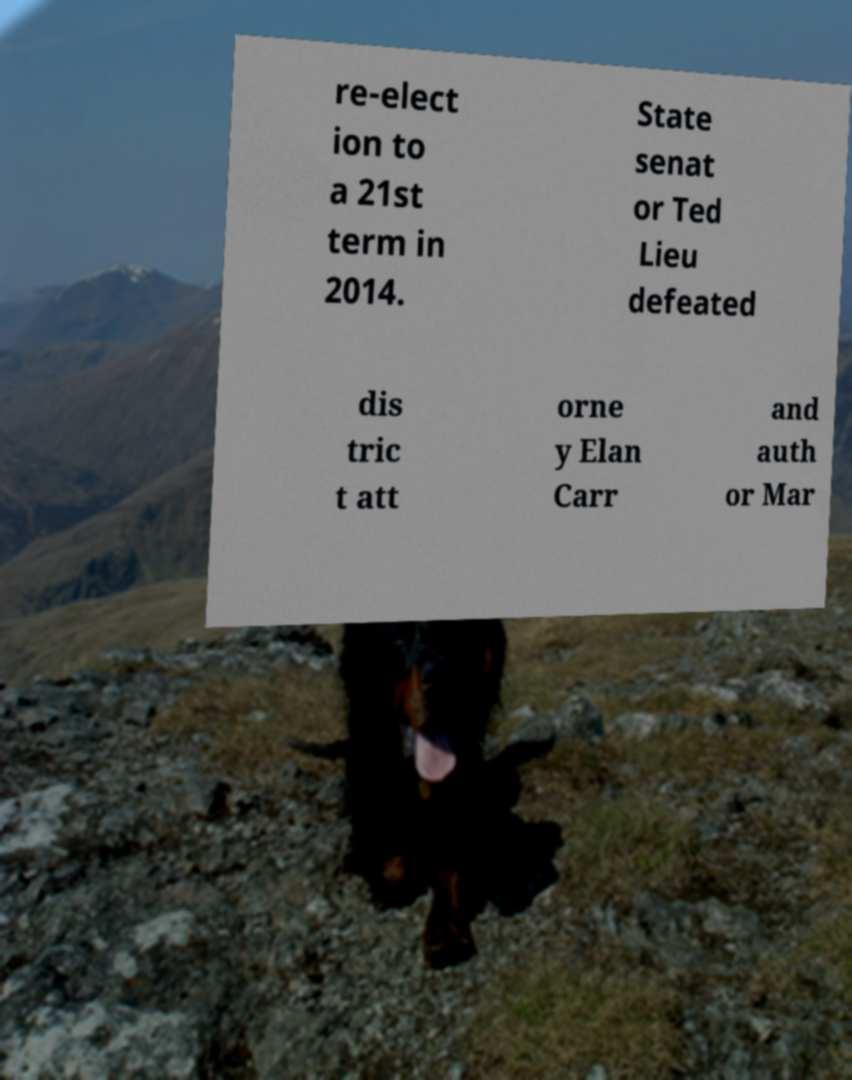There's text embedded in this image that I need extracted. Can you transcribe it verbatim? re-elect ion to a 21st term in 2014. State senat or Ted Lieu defeated dis tric t att orne y Elan Carr and auth or Mar 